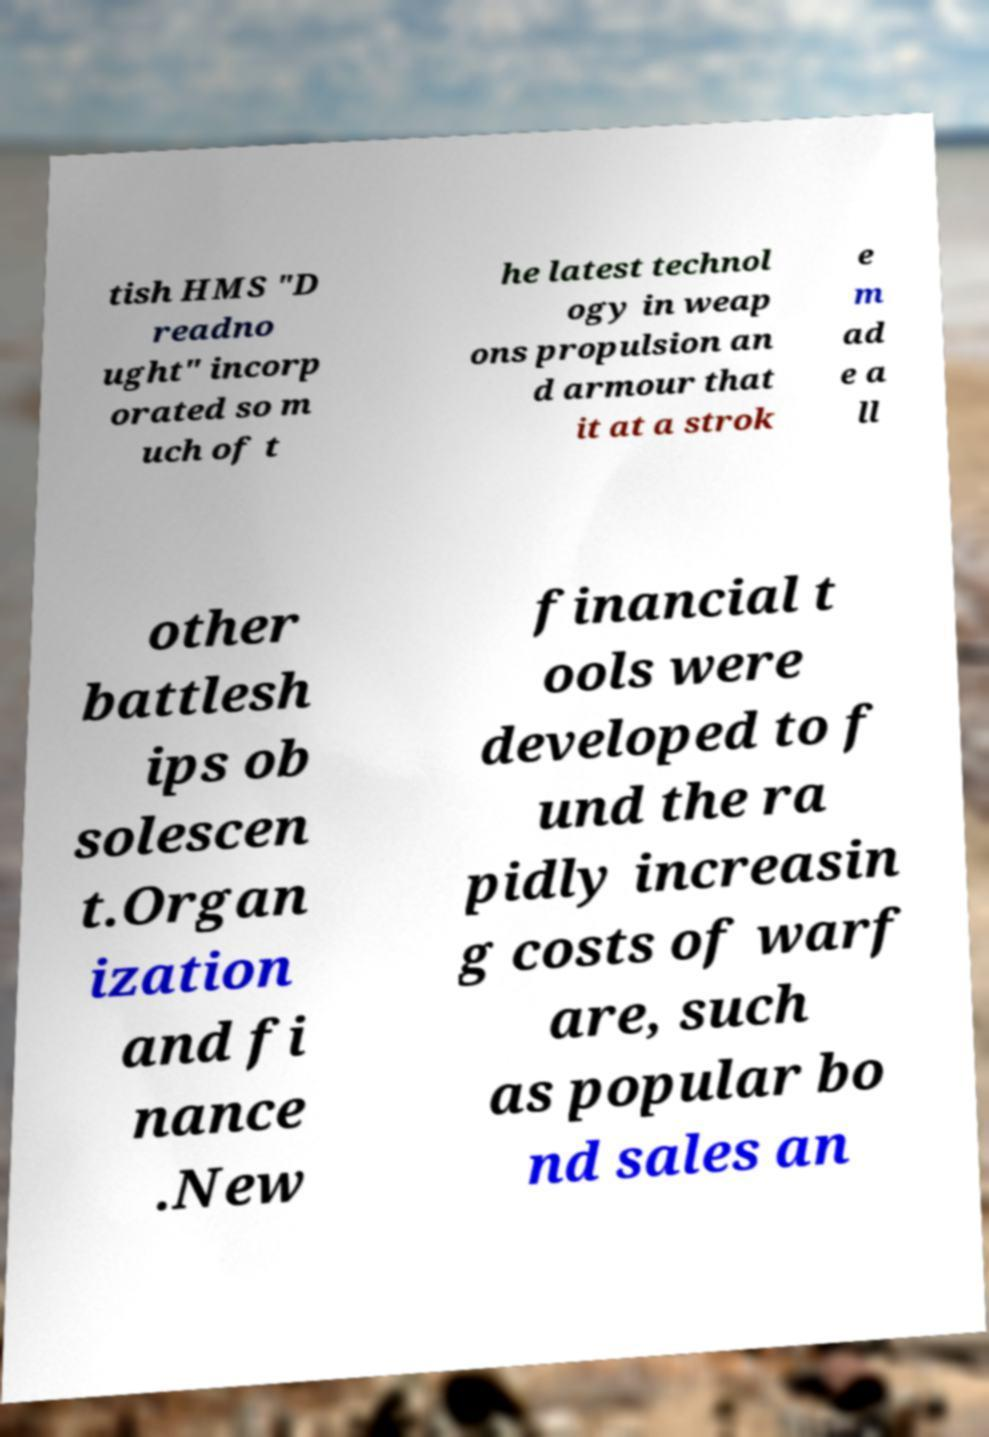Can you accurately transcribe the text from the provided image for me? tish HMS "D readno ught" incorp orated so m uch of t he latest technol ogy in weap ons propulsion an d armour that it at a strok e m ad e a ll other battlesh ips ob solescen t.Organ ization and fi nance .New financial t ools were developed to f und the ra pidly increasin g costs of warf are, such as popular bo nd sales an 